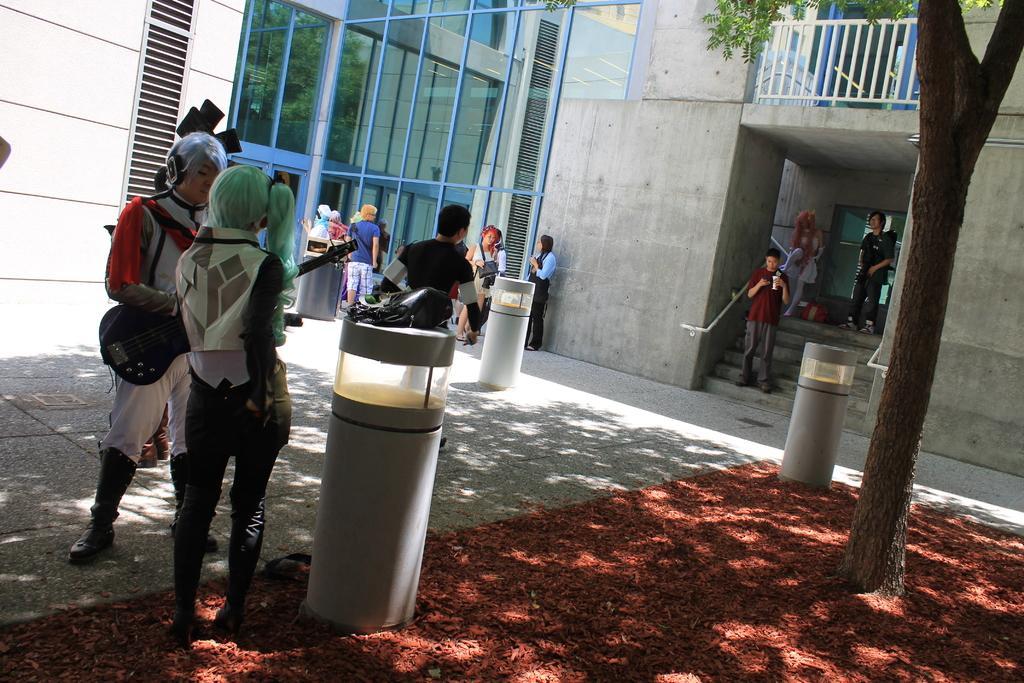How would you summarize this image in a sentence or two? On the right side there is a tree. Also there are poles. There are many people. And a person is wearing headphones and guitar. And there is a building with glass wall, steps and railing. 